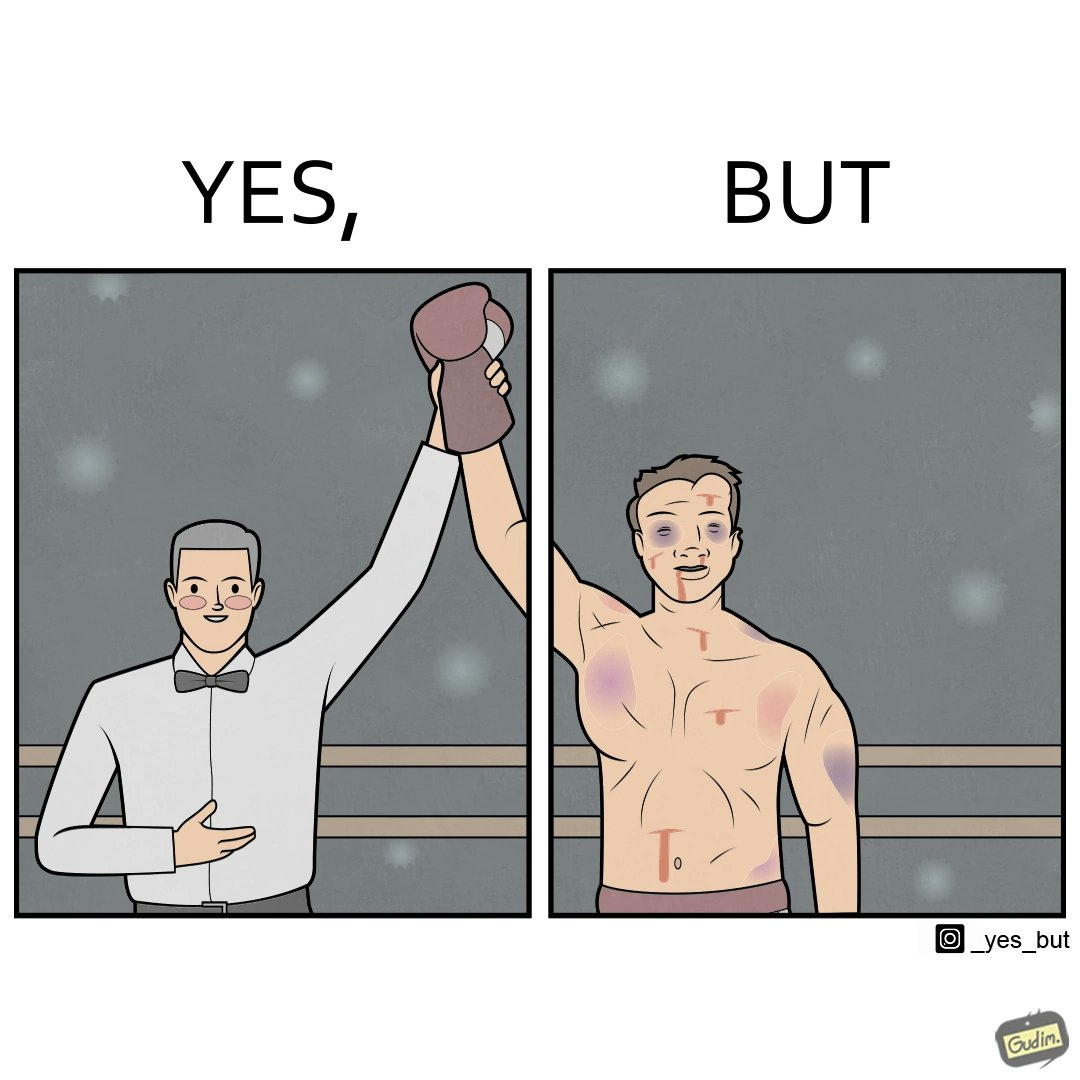Does this image contain satire or humor? Yes, this image is satirical. 